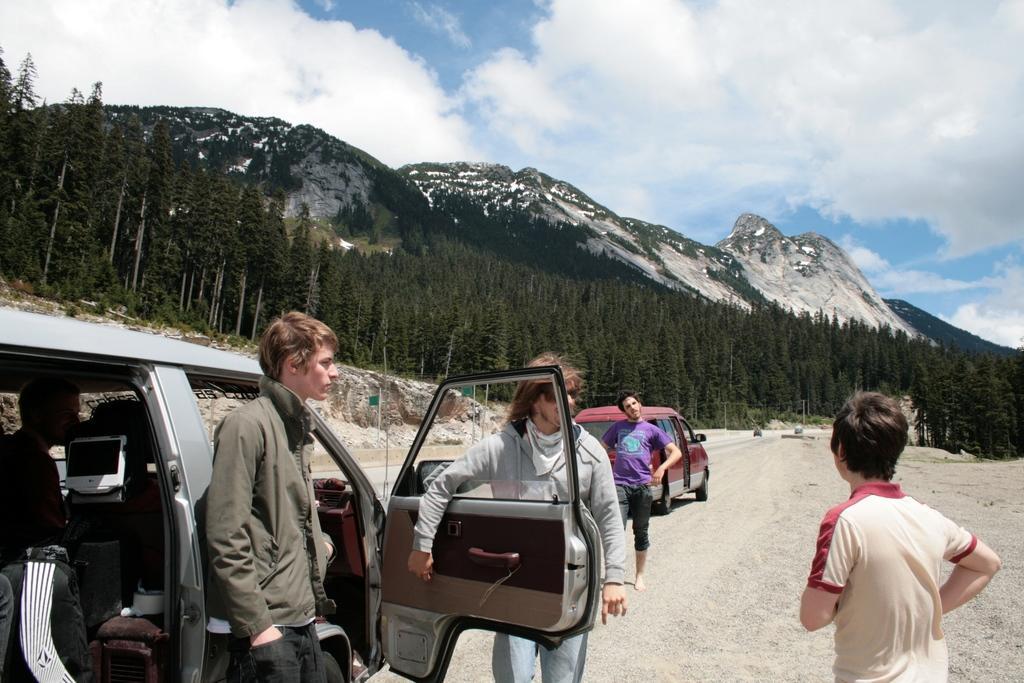Could you give a brief overview of what you see in this image? 3 persons are standing near the vehicle. There are trees ,mountains sky in the middle of an image. 